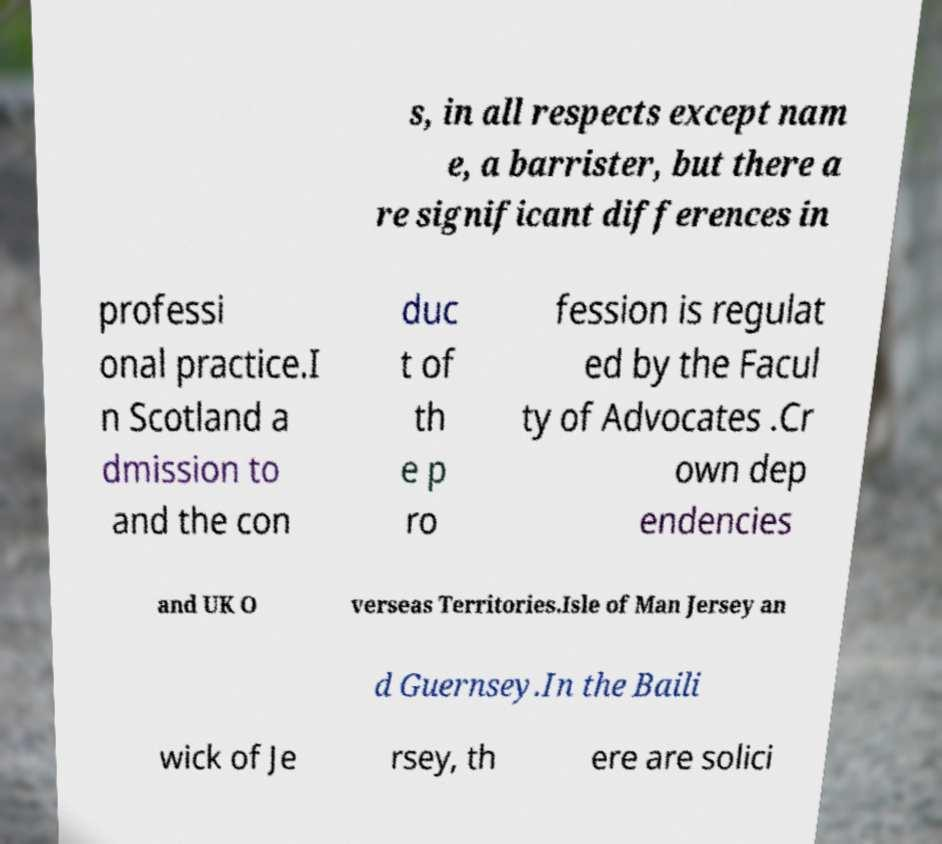Can you accurately transcribe the text from the provided image for me? s, in all respects except nam e, a barrister, but there a re significant differences in professi onal practice.I n Scotland a dmission to and the con duc t of th e p ro fession is regulat ed by the Facul ty of Advocates .Cr own dep endencies and UK O verseas Territories.Isle of Man Jersey an d Guernsey.In the Baili wick of Je rsey, th ere are solici 